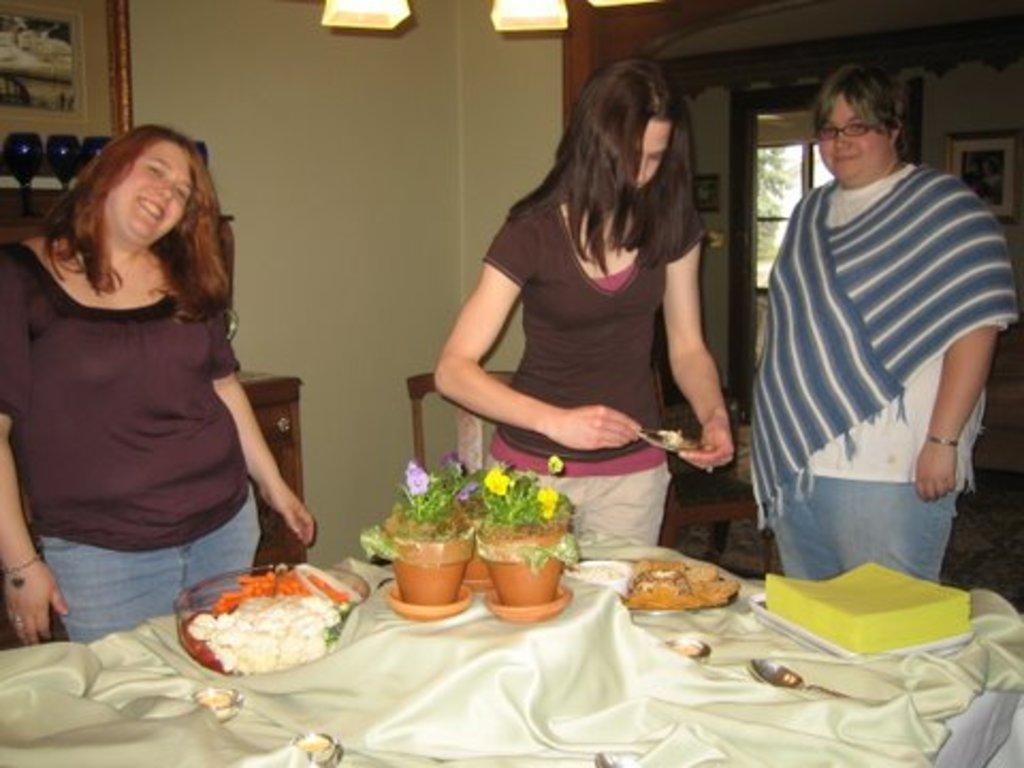In one or two sentences, can you explain what this image depicts? In this picture there are three ladies who are standing in front of the table on which there are two plants, a bowl and some things and behind there is a shelf on which some things are placed and behind there is a window. 